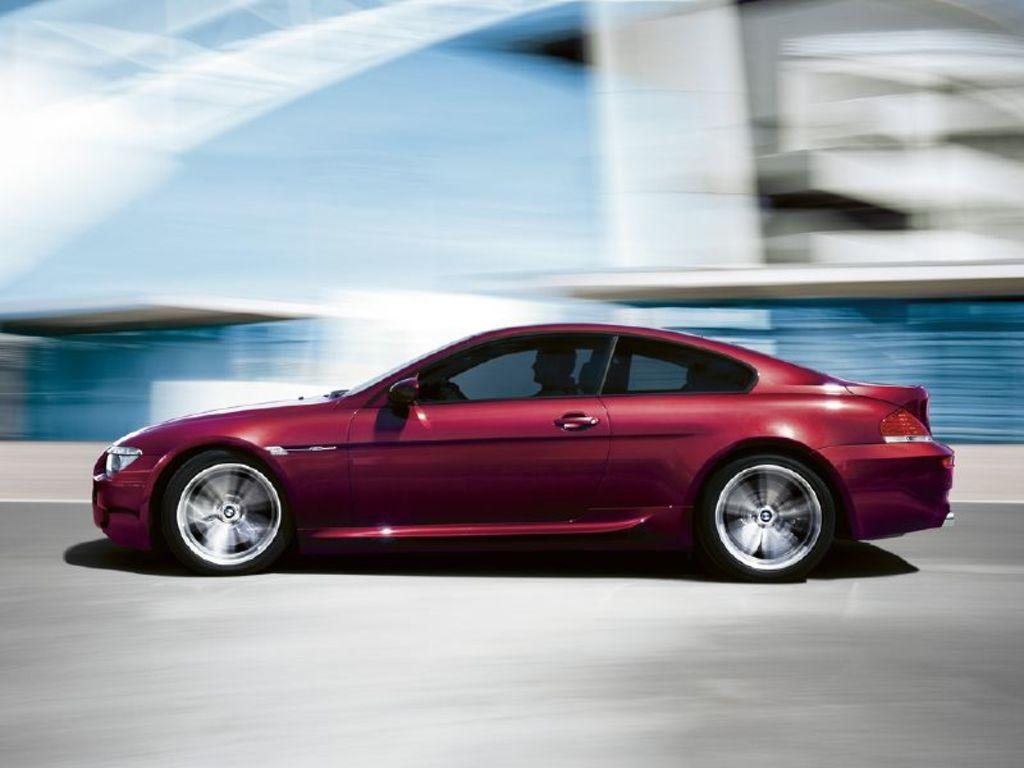What is the main subject of the image? There is a car in the image. Where is the car located? The car is on the road. Can you describe the background of the image? The background of the image is blurry. What type of popcorn is being served in the car? There is no popcorn present in the image. How does the car provide support for the passengers? The car itself does not provide support for passengers; it is the suspension and seatbelts that provide support. 